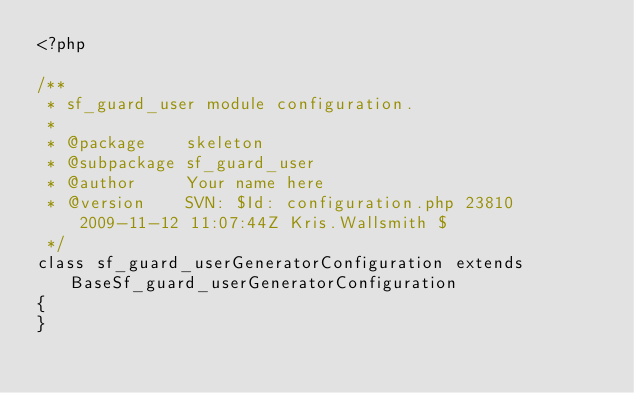Convert code to text. <code><loc_0><loc_0><loc_500><loc_500><_PHP_><?php

/**
 * sf_guard_user module configuration.
 *
 * @package    skeleton
 * @subpackage sf_guard_user
 * @author     Your name here
 * @version    SVN: $Id: configuration.php 23810 2009-11-12 11:07:44Z Kris.Wallsmith $
 */
class sf_guard_userGeneratorConfiguration extends BaseSf_guard_userGeneratorConfiguration
{
}
</code> 